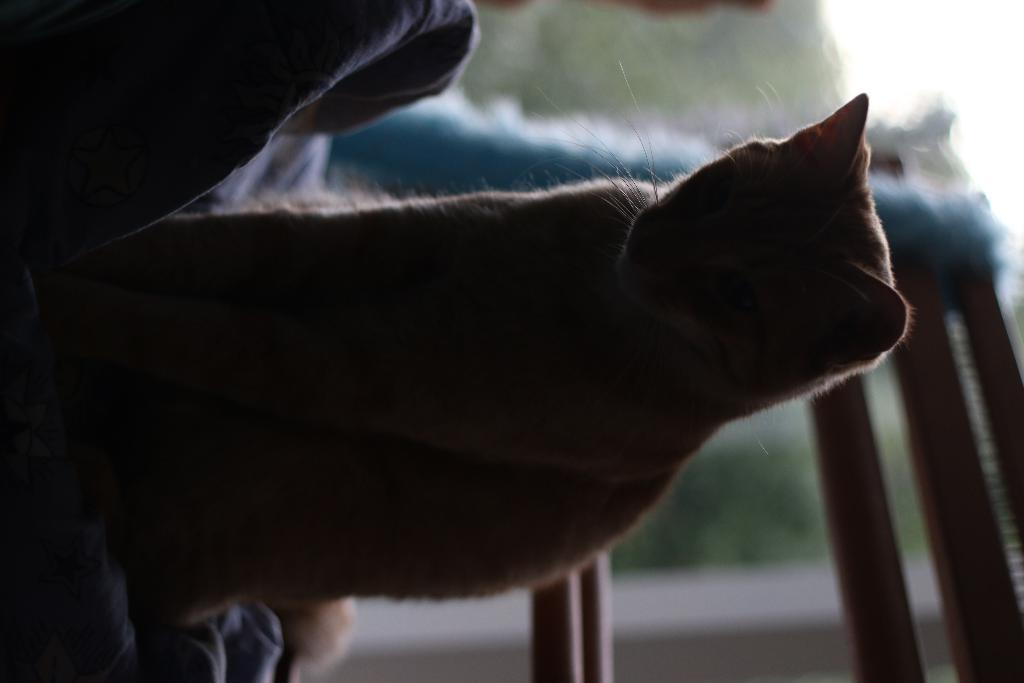What type of animal is in the image? There is a cat in the image. Where is the cat located in the image? The cat is on a human's lap. What type of bells can be heard ringing in the image? There are no bells present in the image, and therefore no sound can be heard. 